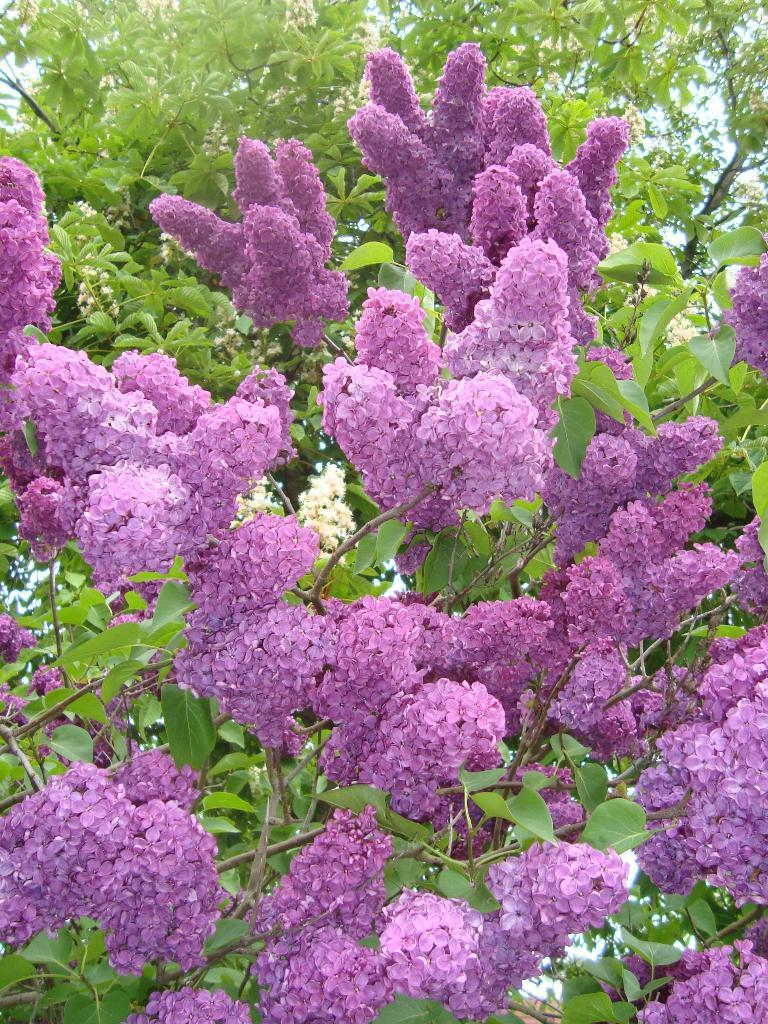What type of plants can be seen in the image? There are flowers in the image. What color are the flowers? The flowers are purple. What can be seen in the background of the image? There are trees in the background of the image. What color are the trees? The trees are green. What part of the natural environment is visible in the image? The sky is visible in the image. What color is the sky? The sky is white. What is the purpose of the dad in the image? There is no dad present in the image, so it's not possible to determine the purpose of a dad. 